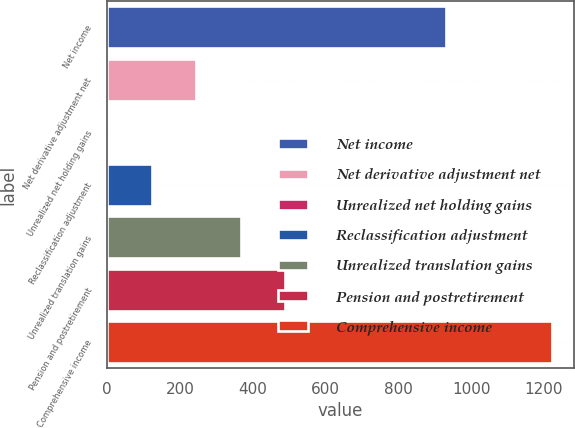Convert chart to OTSL. <chart><loc_0><loc_0><loc_500><loc_500><bar_chart><fcel>Net income<fcel>Net derivative adjustment net<fcel>Unrealized net holding gains<fcel>Reclassification adjustment<fcel>Unrealized translation gains<fcel>Pension and postretirement<fcel>Comprehensive income<nl><fcel>930.6<fcel>244.6<fcel>0.4<fcel>122.5<fcel>366.7<fcel>488.8<fcel>1221.4<nl></chart> 